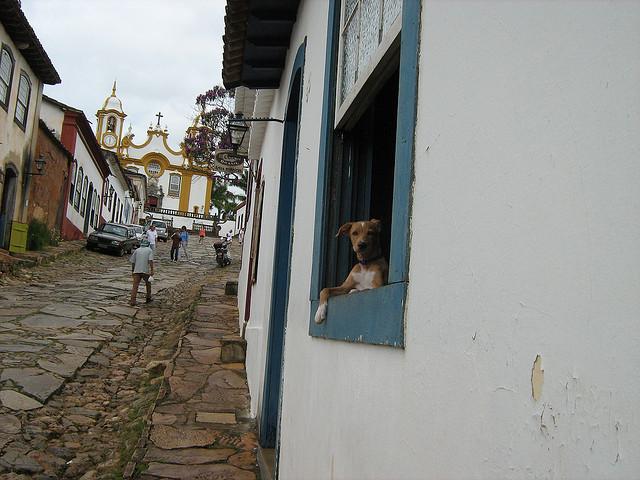Is the dog looking out the window?
Give a very brief answer. Yes. Is anyone walking on the street?
Write a very short answer. Yes. How many motorcycles are there?
Be succinct. 0. Is the walkway paved?
Give a very brief answer. Yes. 